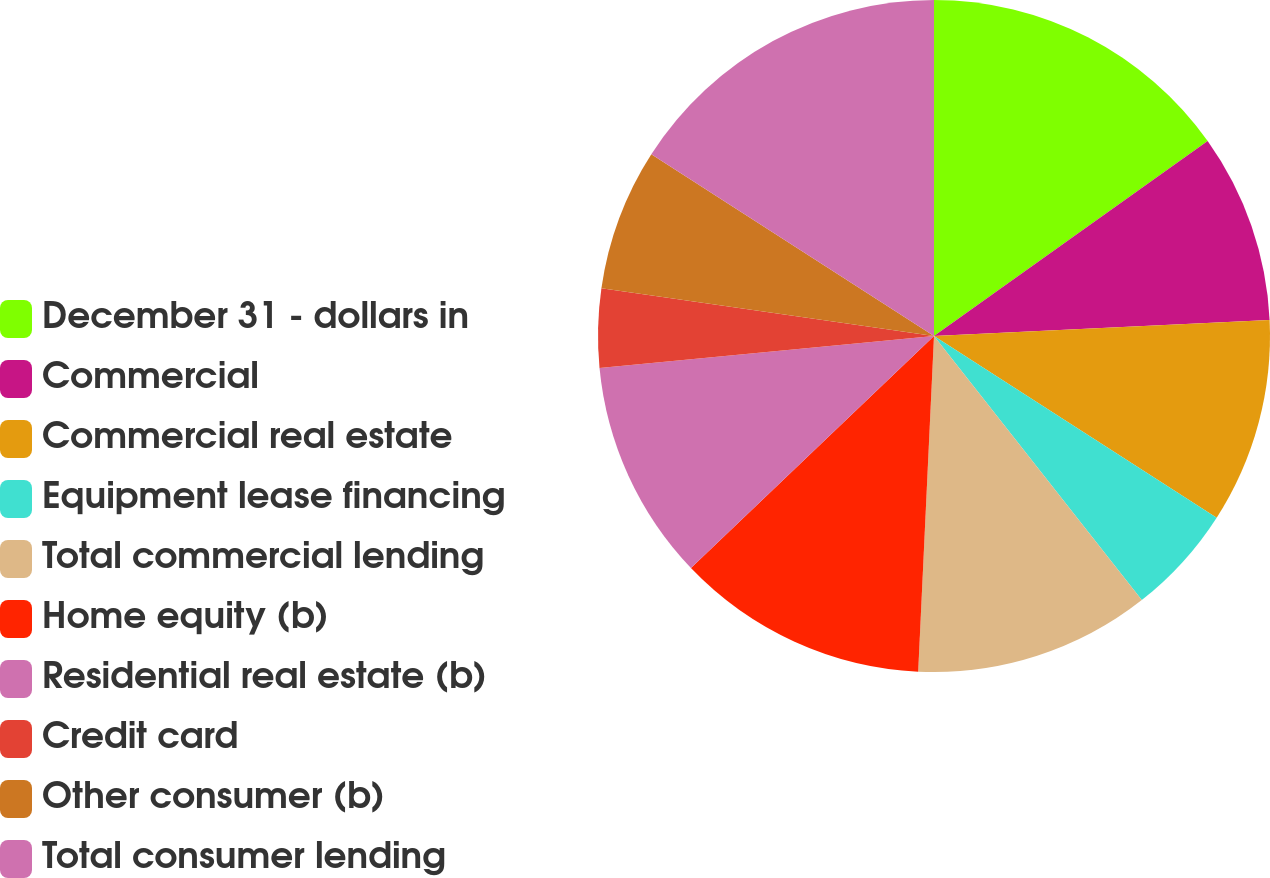Convert chart. <chart><loc_0><loc_0><loc_500><loc_500><pie_chart><fcel>December 31 - dollars in<fcel>Commercial<fcel>Commercial real estate<fcel>Equipment lease financing<fcel>Total commercial lending<fcel>Home equity (b)<fcel>Residential real estate (b)<fcel>Credit card<fcel>Other consumer (b)<fcel>Total consumer lending<nl><fcel>15.15%<fcel>9.09%<fcel>9.85%<fcel>5.3%<fcel>11.36%<fcel>12.12%<fcel>10.61%<fcel>3.79%<fcel>6.82%<fcel>15.91%<nl></chart> 